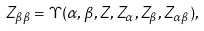<formula> <loc_0><loc_0><loc_500><loc_500>Z _ { \beta \beta } = \Upsilon ( \alpha , \beta , Z , Z _ { \alpha } , Z _ { \beta } , Z _ { \alpha \beta } ) ,</formula> 